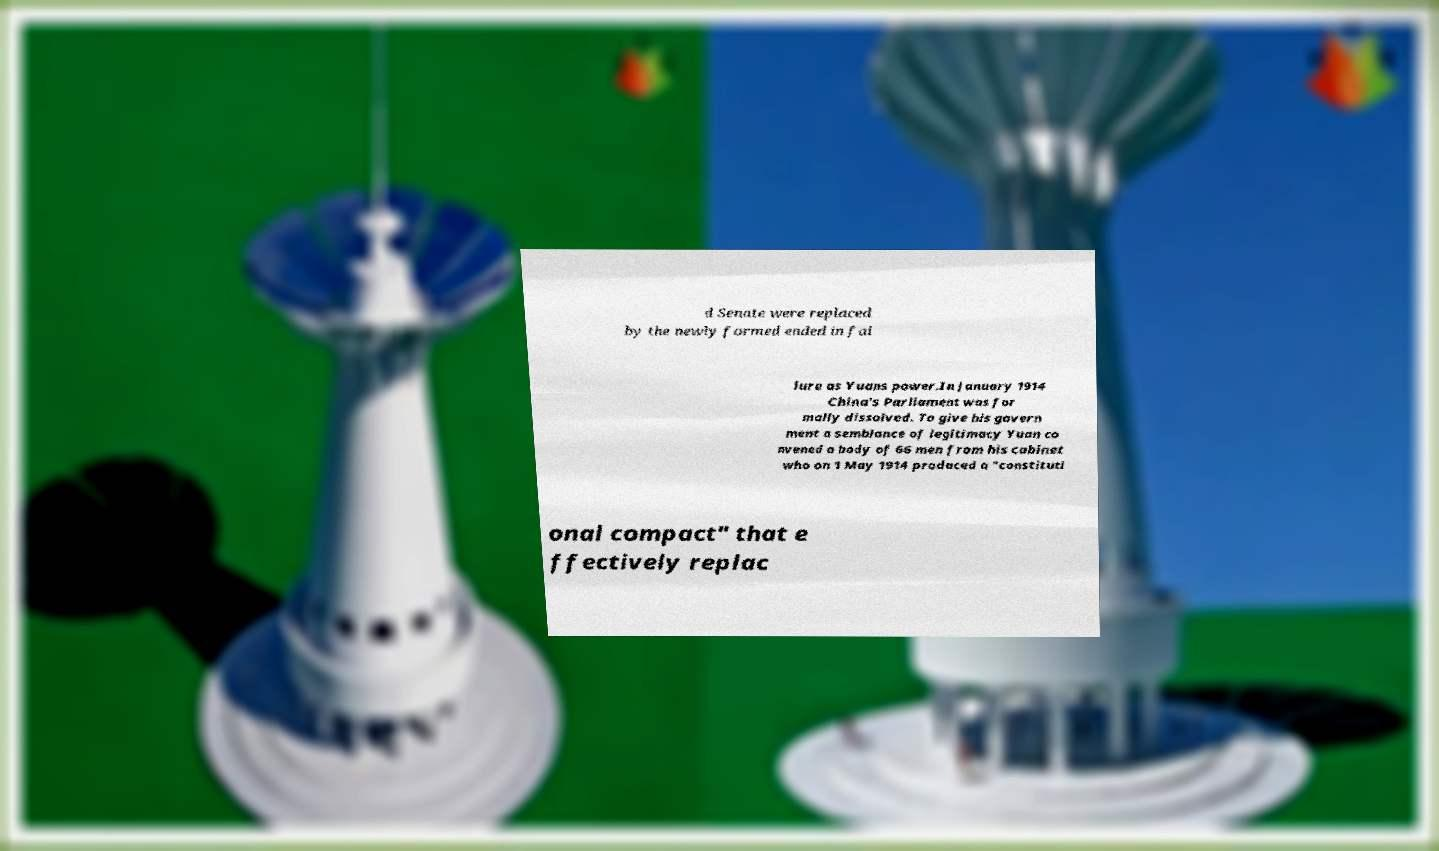What messages or text are displayed in this image? I need them in a readable, typed format. d Senate were replaced by the newly formed ended in fai lure as Yuans power.In January 1914 China's Parliament was for mally dissolved. To give his govern ment a semblance of legitimacy Yuan co nvened a body of 66 men from his cabinet who on 1 May 1914 produced a "constituti onal compact" that e ffectively replac 